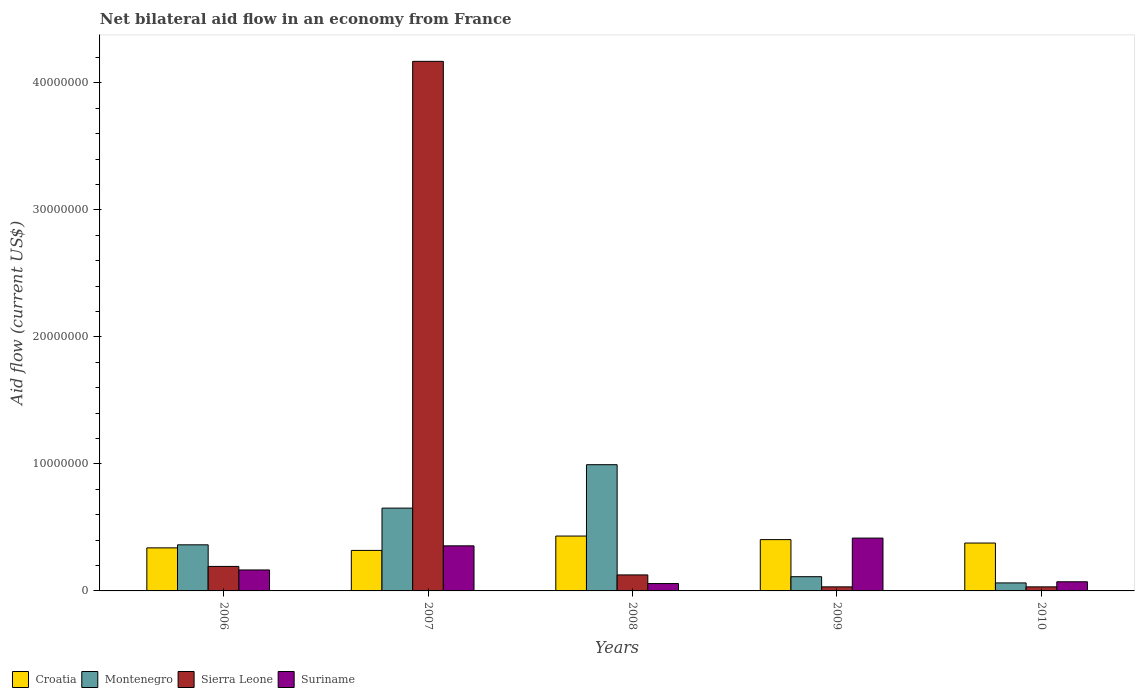How many different coloured bars are there?
Offer a terse response. 4. Are the number of bars per tick equal to the number of legend labels?
Provide a succinct answer. Yes. What is the label of the 4th group of bars from the left?
Offer a very short reply. 2009. In how many cases, is the number of bars for a given year not equal to the number of legend labels?
Keep it short and to the point. 0. What is the net bilateral aid flow in Sierra Leone in 2008?
Provide a succinct answer. 1.26e+06. Across all years, what is the maximum net bilateral aid flow in Montenegro?
Keep it short and to the point. 9.94e+06. Across all years, what is the minimum net bilateral aid flow in Montenegro?
Your response must be concise. 6.30e+05. In which year was the net bilateral aid flow in Sierra Leone maximum?
Your answer should be compact. 2007. What is the total net bilateral aid flow in Montenegro in the graph?
Ensure brevity in your answer.  2.18e+07. What is the difference between the net bilateral aid flow in Montenegro in 2007 and that in 2010?
Make the answer very short. 5.89e+06. What is the difference between the net bilateral aid flow in Montenegro in 2008 and the net bilateral aid flow in Croatia in 2009?
Offer a terse response. 5.90e+06. What is the average net bilateral aid flow in Croatia per year?
Give a very brief answer. 3.74e+06. In the year 2009, what is the difference between the net bilateral aid flow in Sierra Leone and net bilateral aid flow in Croatia?
Your answer should be very brief. -3.72e+06. What is the ratio of the net bilateral aid flow in Suriname in 2007 to that in 2010?
Your answer should be compact. 4.93. Is the net bilateral aid flow in Montenegro in 2007 less than that in 2009?
Your response must be concise. No. Is the difference between the net bilateral aid flow in Sierra Leone in 2006 and 2008 greater than the difference between the net bilateral aid flow in Croatia in 2006 and 2008?
Ensure brevity in your answer.  Yes. What is the difference between the highest and the lowest net bilateral aid flow in Suriname?
Offer a terse response. 3.58e+06. In how many years, is the net bilateral aid flow in Suriname greater than the average net bilateral aid flow in Suriname taken over all years?
Offer a terse response. 2. Is it the case that in every year, the sum of the net bilateral aid flow in Montenegro and net bilateral aid flow in Suriname is greater than the sum of net bilateral aid flow in Sierra Leone and net bilateral aid flow in Croatia?
Provide a succinct answer. No. What does the 1st bar from the left in 2009 represents?
Ensure brevity in your answer.  Croatia. What does the 4th bar from the right in 2006 represents?
Your answer should be very brief. Croatia. How many bars are there?
Offer a terse response. 20. Are all the bars in the graph horizontal?
Offer a very short reply. No. What is the title of the graph?
Provide a short and direct response. Net bilateral aid flow in an economy from France. Does "Ecuador" appear as one of the legend labels in the graph?
Offer a very short reply. No. What is the label or title of the Y-axis?
Your response must be concise. Aid flow (current US$). What is the Aid flow (current US$) in Croatia in 2006?
Give a very brief answer. 3.39e+06. What is the Aid flow (current US$) of Montenegro in 2006?
Provide a short and direct response. 3.63e+06. What is the Aid flow (current US$) in Sierra Leone in 2006?
Offer a terse response. 1.93e+06. What is the Aid flow (current US$) in Suriname in 2006?
Your answer should be very brief. 1.65e+06. What is the Aid flow (current US$) in Croatia in 2007?
Offer a very short reply. 3.19e+06. What is the Aid flow (current US$) in Montenegro in 2007?
Make the answer very short. 6.52e+06. What is the Aid flow (current US$) in Sierra Leone in 2007?
Keep it short and to the point. 4.17e+07. What is the Aid flow (current US$) in Suriname in 2007?
Your answer should be very brief. 3.55e+06. What is the Aid flow (current US$) of Croatia in 2008?
Offer a very short reply. 4.32e+06. What is the Aid flow (current US$) of Montenegro in 2008?
Make the answer very short. 9.94e+06. What is the Aid flow (current US$) of Sierra Leone in 2008?
Provide a short and direct response. 1.26e+06. What is the Aid flow (current US$) of Suriname in 2008?
Your response must be concise. 5.80e+05. What is the Aid flow (current US$) in Croatia in 2009?
Your answer should be very brief. 4.04e+06. What is the Aid flow (current US$) of Montenegro in 2009?
Keep it short and to the point. 1.12e+06. What is the Aid flow (current US$) in Suriname in 2009?
Your answer should be very brief. 4.16e+06. What is the Aid flow (current US$) in Croatia in 2010?
Offer a terse response. 3.77e+06. What is the Aid flow (current US$) in Montenegro in 2010?
Offer a terse response. 6.30e+05. What is the Aid flow (current US$) in Sierra Leone in 2010?
Give a very brief answer. 3.20e+05. What is the Aid flow (current US$) in Suriname in 2010?
Offer a terse response. 7.20e+05. Across all years, what is the maximum Aid flow (current US$) in Croatia?
Your answer should be compact. 4.32e+06. Across all years, what is the maximum Aid flow (current US$) in Montenegro?
Ensure brevity in your answer.  9.94e+06. Across all years, what is the maximum Aid flow (current US$) in Sierra Leone?
Provide a succinct answer. 4.17e+07. Across all years, what is the maximum Aid flow (current US$) in Suriname?
Give a very brief answer. 4.16e+06. Across all years, what is the minimum Aid flow (current US$) in Croatia?
Make the answer very short. 3.19e+06. Across all years, what is the minimum Aid flow (current US$) in Montenegro?
Provide a short and direct response. 6.30e+05. Across all years, what is the minimum Aid flow (current US$) in Suriname?
Provide a short and direct response. 5.80e+05. What is the total Aid flow (current US$) in Croatia in the graph?
Make the answer very short. 1.87e+07. What is the total Aid flow (current US$) of Montenegro in the graph?
Your answer should be compact. 2.18e+07. What is the total Aid flow (current US$) in Sierra Leone in the graph?
Offer a terse response. 4.55e+07. What is the total Aid flow (current US$) in Suriname in the graph?
Provide a short and direct response. 1.07e+07. What is the difference between the Aid flow (current US$) of Croatia in 2006 and that in 2007?
Ensure brevity in your answer.  2.00e+05. What is the difference between the Aid flow (current US$) in Montenegro in 2006 and that in 2007?
Make the answer very short. -2.89e+06. What is the difference between the Aid flow (current US$) in Sierra Leone in 2006 and that in 2007?
Your response must be concise. -3.98e+07. What is the difference between the Aid flow (current US$) of Suriname in 2006 and that in 2007?
Make the answer very short. -1.90e+06. What is the difference between the Aid flow (current US$) of Croatia in 2006 and that in 2008?
Keep it short and to the point. -9.30e+05. What is the difference between the Aid flow (current US$) in Montenegro in 2006 and that in 2008?
Offer a very short reply. -6.31e+06. What is the difference between the Aid flow (current US$) of Sierra Leone in 2006 and that in 2008?
Make the answer very short. 6.70e+05. What is the difference between the Aid flow (current US$) of Suriname in 2006 and that in 2008?
Ensure brevity in your answer.  1.07e+06. What is the difference between the Aid flow (current US$) of Croatia in 2006 and that in 2009?
Your response must be concise. -6.50e+05. What is the difference between the Aid flow (current US$) of Montenegro in 2006 and that in 2009?
Ensure brevity in your answer.  2.51e+06. What is the difference between the Aid flow (current US$) in Sierra Leone in 2006 and that in 2009?
Offer a very short reply. 1.61e+06. What is the difference between the Aid flow (current US$) in Suriname in 2006 and that in 2009?
Your answer should be compact. -2.51e+06. What is the difference between the Aid flow (current US$) of Croatia in 2006 and that in 2010?
Give a very brief answer. -3.80e+05. What is the difference between the Aid flow (current US$) in Sierra Leone in 2006 and that in 2010?
Your response must be concise. 1.61e+06. What is the difference between the Aid flow (current US$) in Suriname in 2006 and that in 2010?
Provide a succinct answer. 9.30e+05. What is the difference between the Aid flow (current US$) of Croatia in 2007 and that in 2008?
Make the answer very short. -1.13e+06. What is the difference between the Aid flow (current US$) of Montenegro in 2007 and that in 2008?
Offer a very short reply. -3.42e+06. What is the difference between the Aid flow (current US$) in Sierra Leone in 2007 and that in 2008?
Provide a succinct answer. 4.04e+07. What is the difference between the Aid flow (current US$) of Suriname in 2007 and that in 2008?
Your answer should be compact. 2.97e+06. What is the difference between the Aid flow (current US$) of Croatia in 2007 and that in 2009?
Offer a very short reply. -8.50e+05. What is the difference between the Aid flow (current US$) in Montenegro in 2007 and that in 2009?
Your response must be concise. 5.40e+06. What is the difference between the Aid flow (current US$) in Sierra Leone in 2007 and that in 2009?
Give a very brief answer. 4.14e+07. What is the difference between the Aid flow (current US$) in Suriname in 2007 and that in 2009?
Ensure brevity in your answer.  -6.10e+05. What is the difference between the Aid flow (current US$) of Croatia in 2007 and that in 2010?
Offer a terse response. -5.80e+05. What is the difference between the Aid flow (current US$) in Montenegro in 2007 and that in 2010?
Your answer should be compact. 5.89e+06. What is the difference between the Aid flow (current US$) of Sierra Leone in 2007 and that in 2010?
Your answer should be compact. 4.14e+07. What is the difference between the Aid flow (current US$) in Suriname in 2007 and that in 2010?
Keep it short and to the point. 2.83e+06. What is the difference between the Aid flow (current US$) in Montenegro in 2008 and that in 2009?
Offer a very short reply. 8.82e+06. What is the difference between the Aid flow (current US$) in Sierra Leone in 2008 and that in 2009?
Provide a short and direct response. 9.40e+05. What is the difference between the Aid flow (current US$) of Suriname in 2008 and that in 2009?
Your answer should be very brief. -3.58e+06. What is the difference between the Aid flow (current US$) in Montenegro in 2008 and that in 2010?
Give a very brief answer. 9.31e+06. What is the difference between the Aid flow (current US$) in Sierra Leone in 2008 and that in 2010?
Your answer should be very brief. 9.40e+05. What is the difference between the Aid flow (current US$) in Suriname in 2009 and that in 2010?
Offer a terse response. 3.44e+06. What is the difference between the Aid flow (current US$) of Croatia in 2006 and the Aid flow (current US$) of Montenegro in 2007?
Ensure brevity in your answer.  -3.13e+06. What is the difference between the Aid flow (current US$) of Croatia in 2006 and the Aid flow (current US$) of Sierra Leone in 2007?
Ensure brevity in your answer.  -3.83e+07. What is the difference between the Aid flow (current US$) of Montenegro in 2006 and the Aid flow (current US$) of Sierra Leone in 2007?
Ensure brevity in your answer.  -3.81e+07. What is the difference between the Aid flow (current US$) of Montenegro in 2006 and the Aid flow (current US$) of Suriname in 2007?
Ensure brevity in your answer.  8.00e+04. What is the difference between the Aid flow (current US$) of Sierra Leone in 2006 and the Aid flow (current US$) of Suriname in 2007?
Keep it short and to the point. -1.62e+06. What is the difference between the Aid flow (current US$) in Croatia in 2006 and the Aid flow (current US$) in Montenegro in 2008?
Keep it short and to the point. -6.55e+06. What is the difference between the Aid flow (current US$) of Croatia in 2006 and the Aid flow (current US$) of Sierra Leone in 2008?
Ensure brevity in your answer.  2.13e+06. What is the difference between the Aid flow (current US$) in Croatia in 2006 and the Aid flow (current US$) in Suriname in 2008?
Provide a succinct answer. 2.81e+06. What is the difference between the Aid flow (current US$) in Montenegro in 2006 and the Aid flow (current US$) in Sierra Leone in 2008?
Provide a short and direct response. 2.37e+06. What is the difference between the Aid flow (current US$) in Montenegro in 2006 and the Aid flow (current US$) in Suriname in 2008?
Make the answer very short. 3.05e+06. What is the difference between the Aid flow (current US$) in Sierra Leone in 2006 and the Aid flow (current US$) in Suriname in 2008?
Provide a short and direct response. 1.35e+06. What is the difference between the Aid flow (current US$) in Croatia in 2006 and the Aid flow (current US$) in Montenegro in 2009?
Provide a short and direct response. 2.27e+06. What is the difference between the Aid flow (current US$) of Croatia in 2006 and the Aid flow (current US$) of Sierra Leone in 2009?
Keep it short and to the point. 3.07e+06. What is the difference between the Aid flow (current US$) in Croatia in 2006 and the Aid flow (current US$) in Suriname in 2009?
Your answer should be very brief. -7.70e+05. What is the difference between the Aid flow (current US$) in Montenegro in 2006 and the Aid flow (current US$) in Sierra Leone in 2009?
Offer a very short reply. 3.31e+06. What is the difference between the Aid flow (current US$) in Montenegro in 2006 and the Aid flow (current US$) in Suriname in 2009?
Make the answer very short. -5.30e+05. What is the difference between the Aid flow (current US$) in Sierra Leone in 2006 and the Aid flow (current US$) in Suriname in 2009?
Offer a terse response. -2.23e+06. What is the difference between the Aid flow (current US$) in Croatia in 2006 and the Aid flow (current US$) in Montenegro in 2010?
Provide a short and direct response. 2.76e+06. What is the difference between the Aid flow (current US$) in Croatia in 2006 and the Aid flow (current US$) in Sierra Leone in 2010?
Provide a succinct answer. 3.07e+06. What is the difference between the Aid flow (current US$) in Croatia in 2006 and the Aid flow (current US$) in Suriname in 2010?
Provide a short and direct response. 2.67e+06. What is the difference between the Aid flow (current US$) in Montenegro in 2006 and the Aid flow (current US$) in Sierra Leone in 2010?
Make the answer very short. 3.31e+06. What is the difference between the Aid flow (current US$) of Montenegro in 2006 and the Aid flow (current US$) of Suriname in 2010?
Your answer should be compact. 2.91e+06. What is the difference between the Aid flow (current US$) in Sierra Leone in 2006 and the Aid flow (current US$) in Suriname in 2010?
Your answer should be compact. 1.21e+06. What is the difference between the Aid flow (current US$) of Croatia in 2007 and the Aid flow (current US$) of Montenegro in 2008?
Make the answer very short. -6.75e+06. What is the difference between the Aid flow (current US$) of Croatia in 2007 and the Aid flow (current US$) of Sierra Leone in 2008?
Your answer should be very brief. 1.93e+06. What is the difference between the Aid flow (current US$) of Croatia in 2007 and the Aid flow (current US$) of Suriname in 2008?
Your response must be concise. 2.61e+06. What is the difference between the Aid flow (current US$) in Montenegro in 2007 and the Aid flow (current US$) in Sierra Leone in 2008?
Ensure brevity in your answer.  5.26e+06. What is the difference between the Aid flow (current US$) of Montenegro in 2007 and the Aid flow (current US$) of Suriname in 2008?
Give a very brief answer. 5.94e+06. What is the difference between the Aid flow (current US$) of Sierra Leone in 2007 and the Aid flow (current US$) of Suriname in 2008?
Make the answer very short. 4.11e+07. What is the difference between the Aid flow (current US$) of Croatia in 2007 and the Aid flow (current US$) of Montenegro in 2009?
Make the answer very short. 2.07e+06. What is the difference between the Aid flow (current US$) of Croatia in 2007 and the Aid flow (current US$) of Sierra Leone in 2009?
Offer a very short reply. 2.87e+06. What is the difference between the Aid flow (current US$) of Croatia in 2007 and the Aid flow (current US$) of Suriname in 2009?
Provide a short and direct response. -9.70e+05. What is the difference between the Aid flow (current US$) in Montenegro in 2007 and the Aid flow (current US$) in Sierra Leone in 2009?
Your response must be concise. 6.20e+06. What is the difference between the Aid flow (current US$) of Montenegro in 2007 and the Aid flow (current US$) of Suriname in 2009?
Your answer should be very brief. 2.36e+06. What is the difference between the Aid flow (current US$) in Sierra Leone in 2007 and the Aid flow (current US$) in Suriname in 2009?
Your response must be concise. 3.75e+07. What is the difference between the Aid flow (current US$) in Croatia in 2007 and the Aid flow (current US$) in Montenegro in 2010?
Make the answer very short. 2.56e+06. What is the difference between the Aid flow (current US$) in Croatia in 2007 and the Aid flow (current US$) in Sierra Leone in 2010?
Offer a very short reply. 2.87e+06. What is the difference between the Aid flow (current US$) in Croatia in 2007 and the Aid flow (current US$) in Suriname in 2010?
Make the answer very short. 2.47e+06. What is the difference between the Aid flow (current US$) of Montenegro in 2007 and the Aid flow (current US$) of Sierra Leone in 2010?
Make the answer very short. 6.20e+06. What is the difference between the Aid flow (current US$) in Montenegro in 2007 and the Aid flow (current US$) in Suriname in 2010?
Offer a very short reply. 5.80e+06. What is the difference between the Aid flow (current US$) of Sierra Leone in 2007 and the Aid flow (current US$) of Suriname in 2010?
Your response must be concise. 4.10e+07. What is the difference between the Aid flow (current US$) in Croatia in 2008 and the Aid flow (current US$) in Montenegro in 2009?
Give a very brief answer. 3.20e+06. What is the difference between the Aid flow (current US$) of Croatia in 2008 and the Aid flow (current US$) of Sierra Leone in 2009?
Your answer should be very brief. 4.00e+06. What is the difference between the Aid flow (current US$) of Croatia in 2008 and the Aid flow (current US$) of Suriname in 2009?
Offer a very short reply. 1.60e+05. What is the difference between the Aid flow (current US$) in Montenegro in 2008 and the Aid flow (current US$) in Sierra Leone in 2009?
Make the answer very short. 9.62e+06. What is the difference between the Aid flow (current US$) of Montenegro in 2008 and the Aid flow (current US$) of Suriname in 2009?
Your answer should be compact. 5.78e+06. What is the difference between the Aid flow (current US$) in Sierra Leone in 2008 and the Aid flow (current US$) in Suriname in 2009?
Your answer should be compact. -2.90e+06. What is the difference between the Aid flow (current US$) of Croatia in 2008 and the Aid flow (current US$) of Montenegro in 2010?
Ensure brevity in your answer.  3.69e+06. What is the difference between the Aid flow (current US$) of Croatia in 2008 and the Aid flow (current US$) of Suriname in 2010?
Give a very brief answer. 3.60e+06. What is the difference between the Aid flow (current US$) in Montenegro in 2008 and the Aid flow (current US$) in Sierra Leone in 2010?
Your answer should be compact. 9.62e+06. What is the difference between the Aid flow (current US$) of Montenegro in 2008 and the Aid flow (current US$) of Suriname in 2010?
Offer a very short reply. 9.22e+06. What is the difference between the Aid flow (current US$) of Sierra Leone in 2008 and the Aid flow (current US$) of Suriname in 2010?
Make the answer very short. 5.40e+05. What is the difference between the Aid flow (current US$) in Croatia in 2009 and the Aid flow (current US$) in Montenegro in 2010?
Your answer should be very brief. 3.41e+06. What is the difference between the Aid flow (current US$) of Croatia in 2009 and the Aid flow (current US$) of Sierra Leone in 2010?
Your answer should be compact. 3.72e+06. What is the difference between the Aid flow (current US$) of Croatia in 2009 and the Aid flow (current US$) of Suriname in 2010?
Your answer should be very brief. 3.32e+06. What is the difference between the Aid flow (current US$) in Montenegro in 2009 and the Aid flow (current US$) in Sierra Leone in 2010?
Keep it short and to the point. 8.00e+05. What is the difference between the Aid flow (current US$) of Montenegro in 2009 and the Aid flow (current US$) of Suriname in 2010?
Your answer should be very brief. 4.00e+05. What is the difference between the Aid flow (current US$) of Sierra Leone in 2009 and the Aid flow (current US$) of Suriname in 2010?
Ensure brevity in your answer.  -4.00e+05. What is the average Aid flow (current US$) of Croatia per year?
Your answer should be very brief. 3.74e+06. What is the average Aid flow (current US$) in Montenegro per year?
Offer a terse response. 4.37e+06. What is the average Aid flow (current US$) in Sierra Leone per year?
Give a very brief answer. 9.11e+06. What is the average Aid flow (current US$) in Suriname per year?
Keep it short and to the point. 2.13e+06. In the year 2006, what is the difference between the Aid flow (current US$) of Croatia and Aid flow (current US$) of Montenegro?
Keep it short and to the point. -2.40e+05. In the year 2006, what is the difference between the Aid flow (current US$) of Croatia and Aid flow (current US$) of Sierra Leone?
Ensure brevity in your answer.  1.46e+06. In the year 2006, what is the difference between the Aid flow (current US$) in Croatia and Aid flow (current US$) in Suriname?
Your response must be concise. 1.74e+06. In the year 2006, what is the difference between the Aid flow (current US$) of Montenegro and Aid flow (current US$) of Sierra Leone?
Make the answer very short. 1.70e+06. In the year 2006, what is the difference between the Aid flow (current US$) of Montenegro and Aid flow (current US$) of Suriname?
Provide a short and direct response. 1.98e+06. In the year 2006, what is the difference between the Aid flow (current US$) of Sierra Leone and Aid flow (current US$) of Suriname?
Give a very brief answer. 2.80e+05. In the year 2007, what is the difference between the Aid flow (current US$) in Croatia and Aid flow (current US$) in Montenegro?
Keep it short and to the point. -3.33e+06. In the year 2007, what is the difference between the Aid flow (current US$) in Croatia and Aid flow (current US$) in Sierra Leone?
Provide a short and direct response. -3.85e+07. In the year 2007, what is the difference between the Aid flow (current US$) of Croatia and Aid flow (current US$) of Suriname?
Your answer should be compact. -3.60e+05. In the year 2007, what is the difference between the Aid flow (current US$) of Montenegro and Aid flow (current US$) of Sierra Leone?
Your answer should be compact. -3.52e+07. In the year 2007, what is the difference between the Aid flow (current US$) in Montenegro and Aid flow (current US$) in Suriname?
Provide a short and direct response. 2.97e+06. In the year 2007, what is the difference between the Aid flow (current US$) of Sierra Leone and Aid flow (current US$) of Suriname?
Provide a short and direct response. 3.82e+07. In the year 2008, what is the difference between the Aid flow (current US$) of Croatia and Aid flow (current US$) of Montenegro?
Ensure brevity in your answer.  -5.62e+06. In the year 2008, what is the difference between the Aid flow (current US$) of Croatia and Aid flow (current US$) of Sierra Leone?
Your answer should be compact. 3.06e+06. In the year 2008, what is the difference between the Aid flow (current US$) in Croatia and Aid flow (current US$) in Suriname?
Give a very brief answer. 3.74e+06. In the year 2008, what is the difference between the Aid flow (current US$) of Montenegro and Aid flow (current US$) of Sierra Leone?
Your response must be concise. 8.68e+06. In the year 2008, what is the difference between the Aid flow (current US$) in Montenegro and Aid flow (current US$) in Suriname?
Keep it short and to the point. 9.36e+06. In the year 2008, what is the difference between the Aid flow (current US$) in Sierra Leone and Aid flow (current US$) in Suriname?
Your response must be concise. 6.80e+05. In the year 2009, what is the difference between the Aid flow (current US$) of Croatia and Aid flow (current US$) of Montenegro?
Give a very brief answer. 2.92e+06. In the year 2009, what is the difference between the Aid flow (current US$) in Croatia and Aid flow (current US$) in Sierra Leone?
Your answer should be compact. 3.72e+06. In the year 2009, what is the difference between the Aid flow (current US$) of Montenegro and Aid flow (current US$) of Suriname?
Provide a short and direct response. -3.04e+06. In the year 2009, what is the difference between the Aid flow (current US$) of Sierra Leone and Aid flow (current US$) of Suriname?
Your response must be concise. -3.84e+06. In the year 2010, what is the difference between the Aid flow (current US$) of Croatia and Aid flow (current US$) of Montenegro?
Give a very brief answer. 3.14e+06. In the year 2010, what is the difference between the Aid flow (current US$) of Croatia and Aid flow (current US$) of Sierra Leone?
Provide a short and direct response. 3.45e+06. In the year 2010, what is the difference between the Aid flow (current US$) of Croatia and Aid flow (current US$) of Suriname?
Keep it short and to the point. 3.05e+06. In the year 2010, what is the difference between the Aid flow (current US$) in Montenegro and Aid flow (current US$) in Sierra Leone?
Provide a short and direct response. 3.10e+05. In the year 2010, what is the difference between the Aid flow (current US$) of Montenegro and Aid flow (current US$) of Suriname?
Provide a succinct answer. -9.00e+04. In the year 2010, what is the difference between the Aid flow (current US$) in Sierra Leone and Aid flow (current US$) in Suriname?
Give a very brief answer. -4.00e+05. What is the ratio of the Aid flow (current US$) in Croatia in 2006 to that in 2007?
Give a very brief answer. 1.06. What is the ratio of the Aid flow (current US$) in Montenegro in 2006 to that in 2007?
Provide a short and direct response. 0.56. What is the ratio of the Aid flow (current US$) in Sierra Leone in 2006 to that in 2007?
Your answer should be very brief. 0.05. What is the ratio of the Aid flow (current US$) in Suriname in 2006 to that in 2007?
Ensure brevity in your answer.  0.46. What is the ratio of the Aid flow (current US$) in Croatia in 2006 to that in 2008?
Your answer should be very brief. 0.78. What is the ratio of the Aid flow (current US$) in Montenegro in 2006 to that in 2008?
Offer a very short reply. 0.37. What is the ratio of the Aid flow (current US$) of Sierra Leone in 2006 to that in 2008?
Ensure brevity in your answer.  1.53. What is the ratio of the Aid flow (current US$) of Suriname in 2006 to that in 2008?
Offer a terse response. 2.84. What is the ratio of the Aid flow (current US$) in Croatia in 2006 to that in 2009?
Provide a short and direct response. 0.84. What is the ratio of the Aid flow (current US$) of Montenegro in 2006 to that in 2009?
Offer a terse response. 3.24. What is the ratio of the Aid flow (current US$) of Sierra Leone in 2006 to that in 2009?
Your answer should be compact. 6.03. What is the ratio of the Aid flow (current US$) in Suriname in 2006 to that in 2009?
Offer a terse response. 0.4. What is the ratio of the Aid flow (current US$) in Croatia in 2006 to that in 2010?
Offer a very short reply. 0.9. What is the ratio of the Aid flow (current US$) of Montenegro in 2006 to that in 2010?
Offer a very short reply. 5.76. What is the ratio of the Aid flow (current US$) in Sierra Leone in 2006 to that in 2010?
Keep it short and to the point. 6.03. What is the ratio of the Aid flow (current US$) in Suriname in 2006 to that in 2010?
Offer a terse response. 2.29. What is the ratio of the Aid flow (current US$) in Croatia in 2007 to that in 2008?
Keep it short and to the point. 0.74. What is the ratio of the Aid flow (current US$) in Montenegro in 2007 to that in 2008?
Your response must be concise. 0.66. What is the ratio of the Aid flow (current US$) of Sierra Leone in 2007 to that in 2008?
Keep it short and to the point. 33.1. What is the ratio of the Aid flow (current US$) of Suriname in 2007 to that in 2008?
Give a very brief answer. 6.12. What is the ratio of the Aid flow (current US$) in Croatia in 2007 to that in 2009?
Keep it short and to the point. 0.79. What is the ratio of the Aid flow (current US$) in Montenegro in 2007 to that in 2009?
Offer a terse response. 5.82. What is the ratio of the Aid flow (current US$) of Sierra Leone in 2007 to that in 2009?
Provide a short and direct response. 130.31. What is the ratio of the Aid flow (current US$) of Suriname in 2007 to that in 2009?
Provide a short and direct response. 0.85. What is the ratio of the Aid flow (current US$) in Croatia in 2007 to that in 2010?
Your response must be concise. 0.85. What is the ratio of the Aid flow (current US$) in Montenegro in 2007 to that in 2010?
Keep it short and to the point. 10.35. What is the ratio of the Aid flow (current US$) of Sierra Leone in 2007 to that in 2010?
Offer a very short reply. 130.31. What is the ratio of the Aid flow (current US$) of Suriname in 2007 to that in 2010?
Provide a short and direct response. 4.93. What is the ratio of the Aid flow (current US$) of Croatia in 2008 to that in 2009?
Provide a succinct answer. 1.07. What is the ratio of the Aid flow (current US$) in Montenegro in 2008 to that in 2009?
Ensure brevity in your answer.  8.88. What is the ratio of the Aid flow (current US$) in Sierra Leone in 2008 to that in 2009?
Keep it short and to the point. 3.94. What is the ratio of the Aid flow (current US$) in Suriname in 2008 to that in 2009?
Your answer should be very brief. 0.14. What is the ratio of the Aid flow (current US$) of Croatia in 2008 to that in 2010?
Ensure brevity in your answer.  1.15. What is the ratio of the Aid flow (current US$) of Montenegro in 2008 to that in 2010?
Your answer should be very brief. 15.78. What is the ratio of the Aid flow (current US$) of Sierra Leone in 2008 to that in 2010?
Offer a very short reply. 3.94. What is the ratio of the Aid flow (current US$) in Suriname in 2008 to that in 2010?
Give a very brief answer. 0.81. What is the ratio of the Aid flow (current US$) of Croatia in 2009 to that in 2010?
Make the answer very short. 1.07. What is the ratio of the Aid flow (current US$) in Montenegro in 2009 to that in 2010?
Provide a short and direct response. 1.78. What is the ratio of the Aid flow (current US$) of Suriname in 2009 to that in 2010?
Your response must be concise. 5.78. What is the difference between the highest and the second highest Aid flow (current US$) of Croatia?
Your response must be concise. 2.80e+05. What is the difference between the highest and the second highest Aid flow (current US$) in Montenegro?
Your answer should be compact. 3.42e+06. What is the difference between the highest and the second highest Aid flow (current US$) of Sierra Leone?
Keep it short and to the point. 3.98e+07. What is the difference between the highest and the lowest Aid flow (current US$) in Croatia?
Give a very brief answer. 1.13e+06. What is the difference between the highest and the lowest Aid flow (current US$) in Montenegro?
Give a very brief answer. 9.31e+06. What is the difference between the highest and the lowest Aid flow (current US$) in Sierra Leone?
Ensure brevity in your answer.  4.14e+07. What is the difference between the highest and the lowest Aid flow (current US$) in Suriname?
Ensure brevity in your answer.  3.58e+06. 